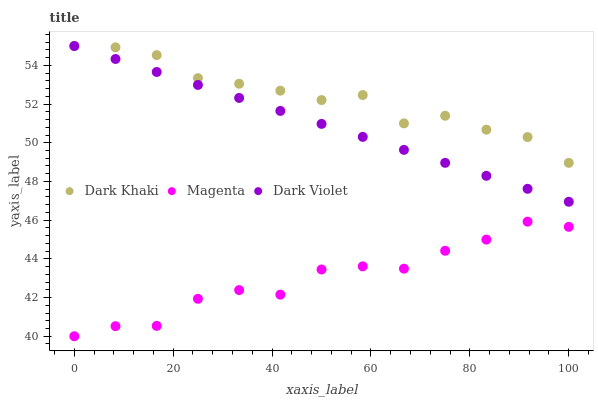Does Magenta have the minimum area under the curve?
Answer yes or no. Yes. Does Dark Khaki have the maximum area under the curve?
Answer yes or no. Yes. Does Dark Violet have the minimum area under the curve?
Answer yes or no. No. Does Dark Violet have the maximum area under the curve?
Answer yes or no. No. Is Dark Violet the smoothest?
Answer yes or no. Yes. Is Magenta the roughest?
Answer yes or no. Yes. Is Magenta the smoothest?
Answer yes or no. No. Is Dark Violet the roughest?
Answer yes or no. No. Does Magenta have the lowest value?
Answer yes or no. Yes. Does Dark Violet have the lowest value?
Answer yes or no. No. Does Dark Violet have the highest value?
Answer yes or no. Yes. Does Magenta have the highest value?
Answer yes or no. No. Is Magenta less than Dark Violet?
Answer yes or no. Yes. Is Dark Violet greater than Magenta?
Answer yes or no. Yes. Does Dark Khaki intersect Dark Violet?
Answer yes or no. Yes. Is Dark Khaki less than Dark Violet?
Answer yes or no. No. Is Dark Khaki greater than Dark Violet?
Answer yes or no. No. Does Magenta intersect Dark Violet?
Answer yes or no. No. 